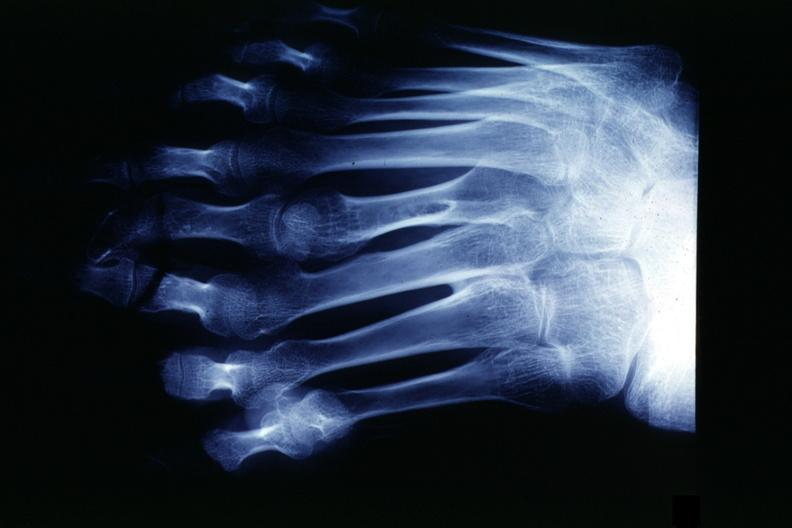does fixed tissue show x-ray strange foot with 8 digits?
Answer the question using a single word or phrase. No 